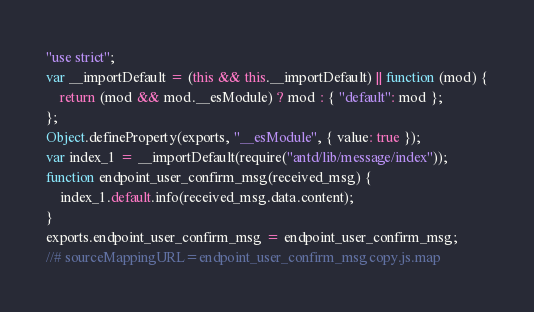Convert code to text. <code><loc_0><loc_0><loc_500><loc_500><_JavaScript_>"use strict";
var __importDefault = (this && this.__importDefault) || function (mod) {
    return (mod && mod.__esModule) ? mod : { "default": mod };
};
Object.defineProperty(exports, "__esModule", { value: true });
var index_1 = __importDefault(require("antd/lib/message/index"));
function endpoint_user_confirm_msg(received_msg) {
    index_1.default.info(received_msg.data.content);
}
exports.endpoint_user_confirm_msg = endpoint_user_confirm_msg;
//# sourceMappingURL=endpoint_user_confirm_msg copy.js.map</code> 